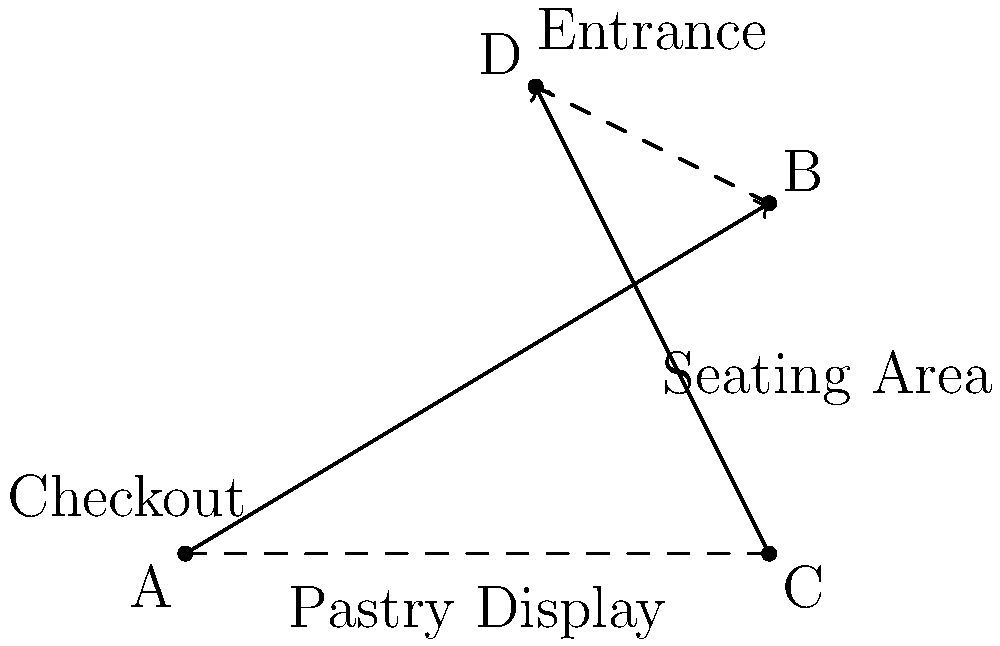In the bakery layout shown above, two paths intersect: one from the Checkout (A) to the Pastry Display (B), and another from the Seating Area (C) to the Entrance (D). If the coordinates of these points are A(0,0), B(5,3), C(5,0), and D(3,4), what is the angle of intersection between these two paths? To find the angle between the two intersecting lines, we can follow these steps:

1) First, we need to find the direction vectors of both lines:
   $\vec{AB} = (5-0, 3-0) = (5, 3)$
   $\vec{CD} = (3-5, 4-0) = (-2, 4)$

2) The angle between two vectors can be found using the dot product formula:
   $\cos \theta = \frac{\vec{a} \cdot \vec{b}}{|\vec{a}||\vec{b}|}$

3) Calculate the dot product $\vec{AB} \cdot \vec{CD}$:
   $(5, 3) \cdot (-2, 4) = -10 + 12 = 2$

4) Calculate the magnitudes:
   $|\vec{AB}| = \sqrt{5^2 + 3^2} = \sqrt{34}$
   $|\vec{CD}| = \sqrt{(-2)^2 + 4^2} = \sqrt{20}$

5) Substitute into the formula:
   $\cos \theta = \frac{2}{\sqrt{34} \cdot \sqrt{20}} = \frac{2}{\sqrt{680}}$

6) Take the inverse cosine (arccos) of both sides:
   $\theta = \arccos(\frac{2}{\sqrt{680}})$

7) Calculate the result:
   $\theta \approx 1.4835$ radians or $85.0°$
Answer: $85.0°$ 